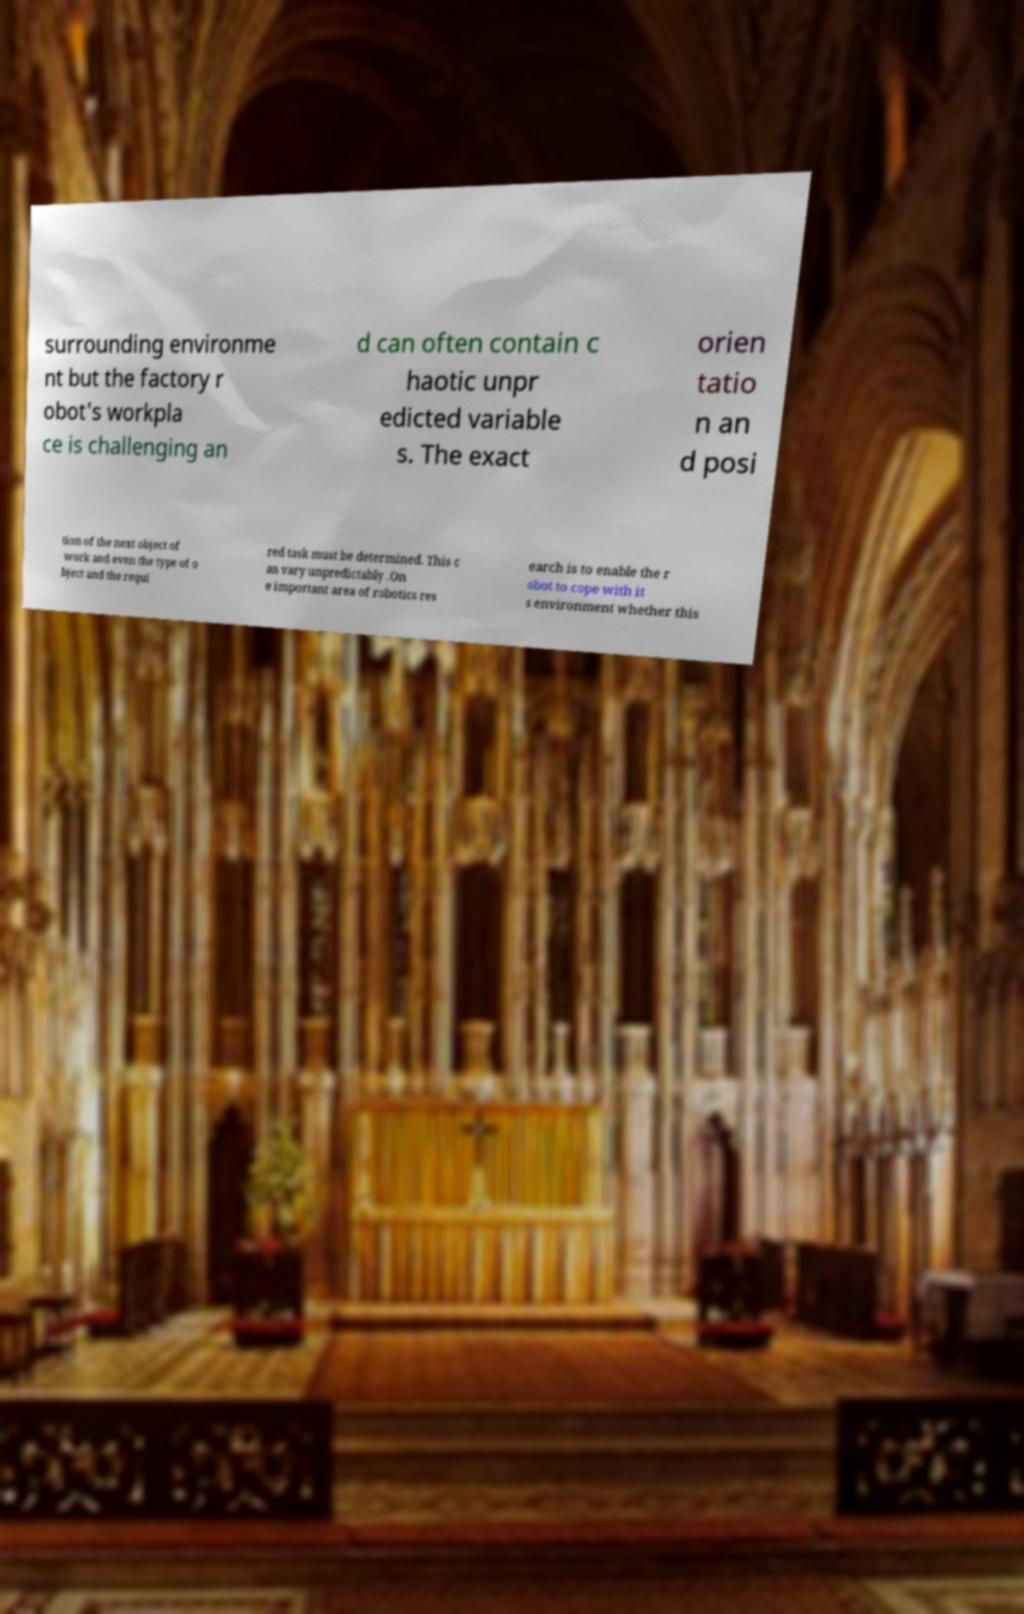Could you extract and type out the text from this image? surrounding environme nt but the factory r obot's workpla ce is challenging an d can often contain c haotic unpr edicted variable s. The exact orien tatio n an d posi tion of the next object of work and even the type of o bject and the requi red task must be determined. This c an vary unpredictably .On e important area of robotics res earch is to enable the r obot to cope with it s environment whether this 